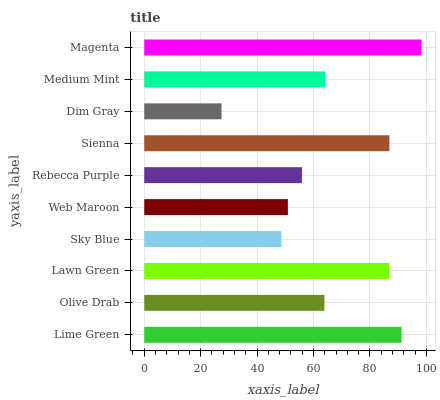Is Dim Gray the minimum?
Answer yes or no. Yes. Is Magenta the maximum?
Answer yes or no. Yes. Is Olive Drab the minimum?
Answer yes or no. No. Is Olive Drab the maximum?
Answer yes or no. No. Is Lime Green greater than Olive Drab?
Answer yes or no. Yes. Is Olive Drab less than Lime Green?
Answer yes or no. Yes. Is Olive Drab greater than Lime Green?
Answer yes or no. No. Is Lime Green less than Olive Drab?
Answer yes or no. No. Is Medium Mint the high median?
Answer yes or no. Yes. Is Olive Drab the low median?
Answer yes or no. Yes. Is Rebecca Purple the high median?
Answer yes or no. No. Is Sienna the low median?
Answer yes or no. No. 